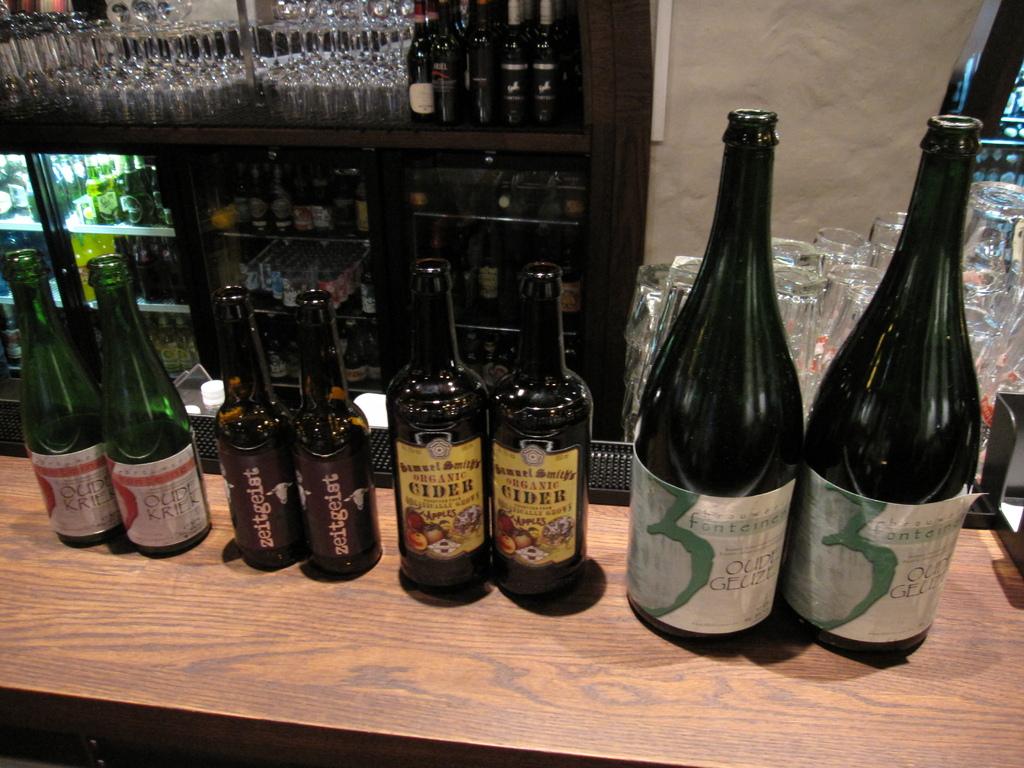What is the name of one of the drinks offered?
Offer a terse response. Cider. What type of drink is in the yellow label bottle?
Offer a terse response. Cider. 